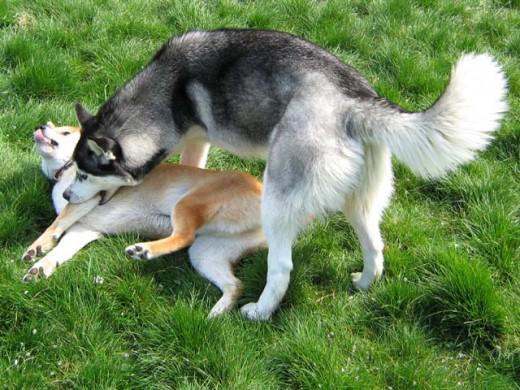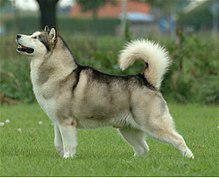The first image is the image on the left, the second image is the image on the right. Evaluate the accuracy of this statement regarding the images: "there are two huskies with their tongue sticking out in the image pair". Is it true? Answer yes or no. No. 